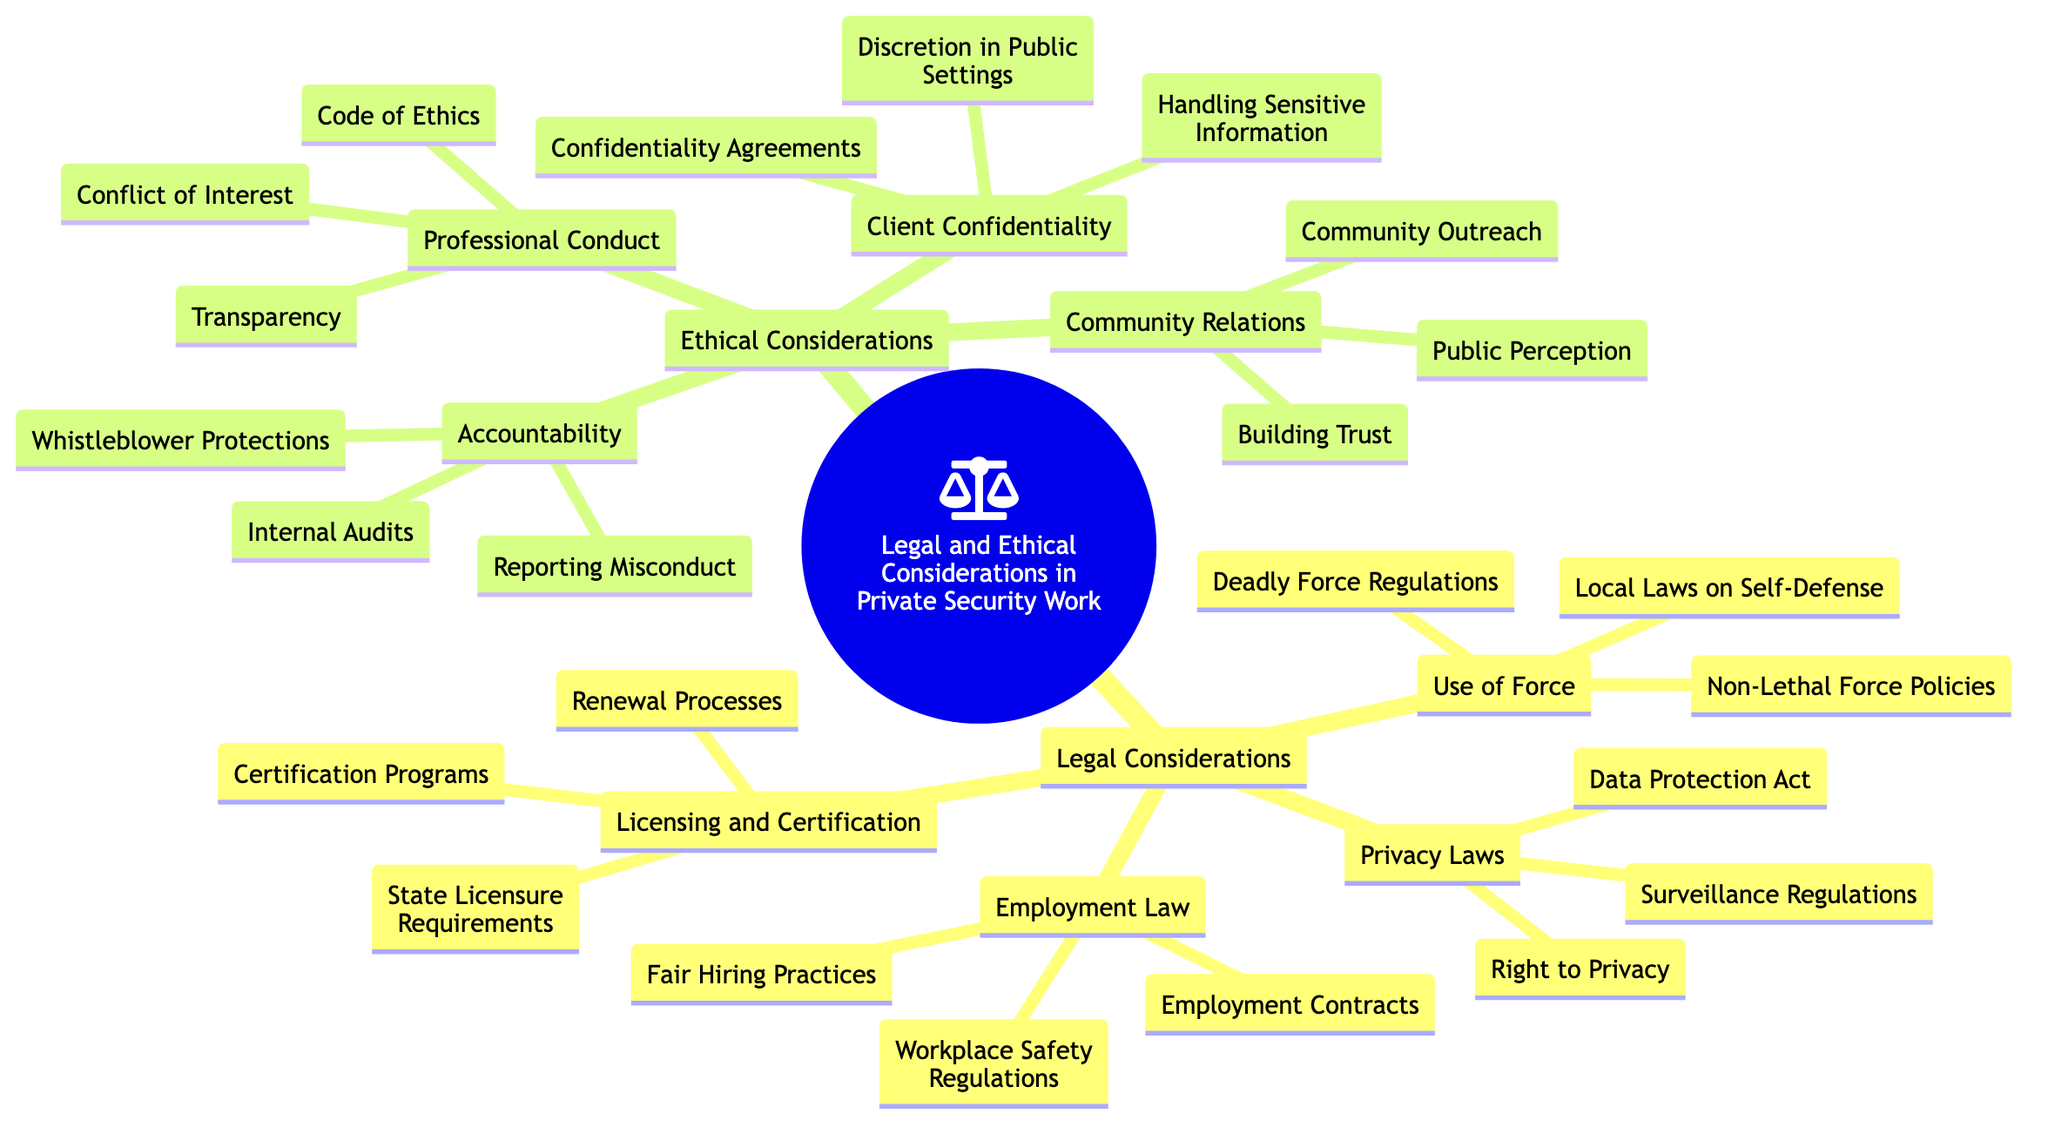What are the three main categories covered in this mind map? The mind map is organized into two main categories: 'Legal Considerations' and 'Ethical Considerations', each further divided into subcategories.
Answer: Legal Considerations, Ethical Considerations How many subcategories are under 'Legal Considerations'? Under 'Legal Considerations', there are four subcategories: Licensing and Certification, Use of Force, Privacy Laws, and Employment Law, which adds up to four subcategories.
Answer: 4 What is one subtopic listed under 'Use of Force'? The 'Use of Force' category includes several subtopics; one of them is 'Local Laws on Self-Defense' which is explicitly mentioned as a subtopic.
Answer: Local Laws on Self-Defense What is the relationship between 'Client Confidentiality' and 'Professional Conduct'? Both 'Client Confidentiality' and 'Professional Conduct' are subcategories under the main category of 'Ethical Considerations,' indicating that they are part of the same broader category relating to ethical practices in security work.
Answer: Ethical Considerations What must accompany the 'Confidentiality Agreements' under 'Client Confidentiality'? 'Confidentiality Agreements' is a subtopic under 'Client Confidentiality', and it is listed alongside 'Handling Sensitive Information' and 'Discretion in Public Settings', indicating they collectively address client confidentiality issues.
Answer: Handling Sensitive Information How many topics are listed under 'Employment Law'? 'Employment Law' consists of three main topics: Fair Hiring Practices, Employment Contracts, and Workplace Safety Regulations, totaling three topics.
Answer: 3 What does the 'Accountability' category cover? The 'Accountability' category includes three important subtopics: Reporting Misconduct, Whistleblower Protections, and Internal Audits, each addressing different aspects of maintaining accountability in security practices.
Answer: Reporting Misconduct, Whistleblower Protections, Internal Audits What ethical aspect aims to foster positive interactions with the community? The 'Community Relations' category specifically addresses the ethical aspect of fostering positive interactions through Building Trust, Community Outreach, and Public Perception, ensuring security officers engage well with the community.
Answer: Building Trust Which category includes 'Data Protection Act'? 'Data Protection Act' is a subtopic under 'Privacy Laws', which falls within the 'Legal Considerations' category, highlighting important legal requirements regarding privacy.
Answer: Privacy Laws 